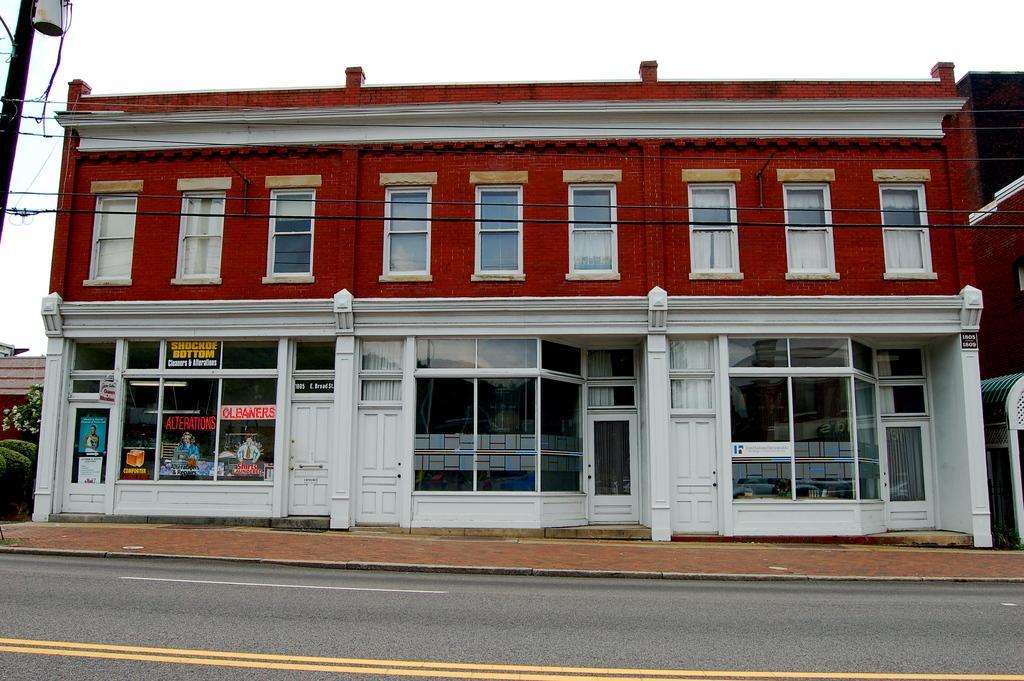Please provide a concise description of this image. In this image I can see a building which is in white and red color. I can see a glass windows and doors. I can see few stickers attached to the wall. I can see wires,trees and pole. The sky is in white color. 